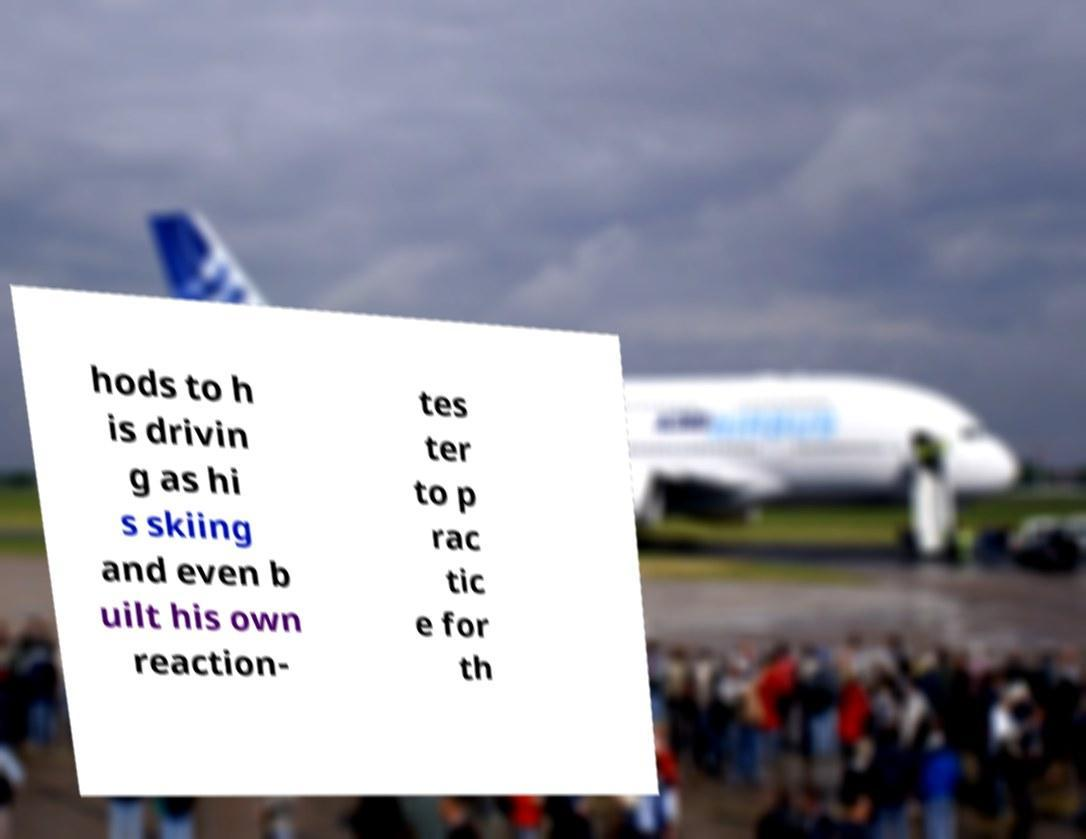Could you extract and type out the text from this image? hods to h is drivin g as hi s skiing and even b uilt his own reaction- tes ter to p rac tic e for th 